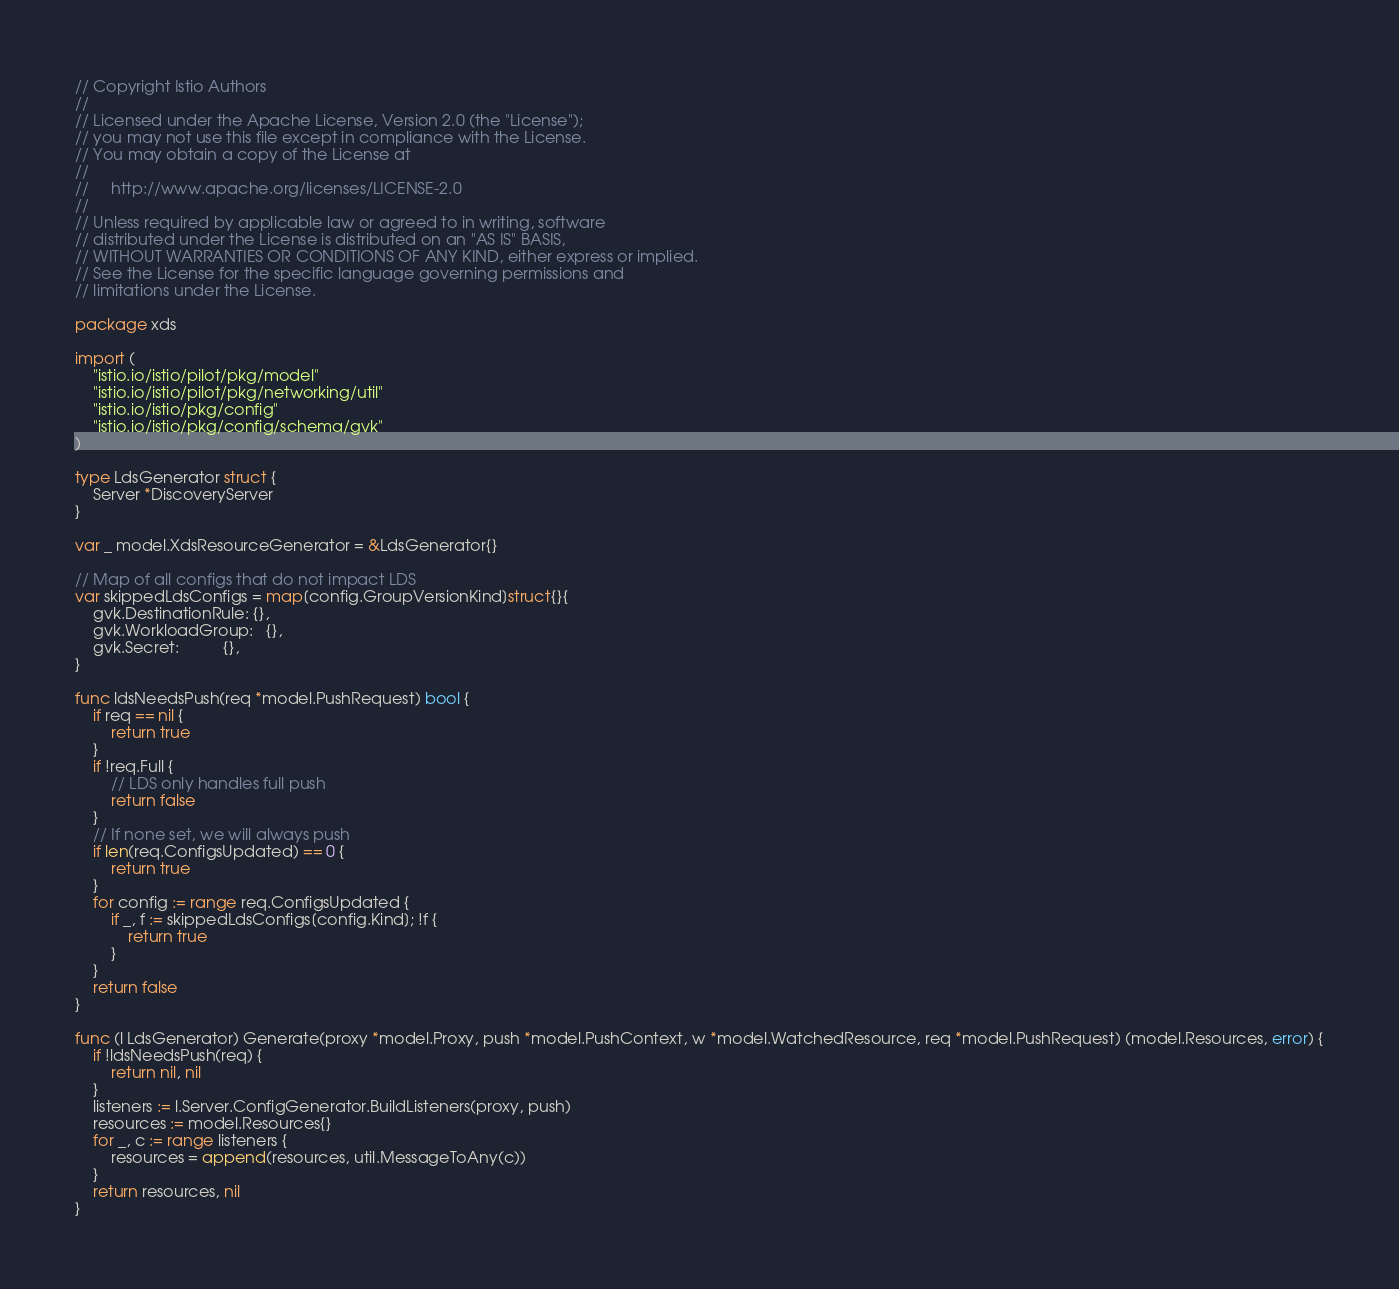Convert code to text. <code><loc_0><loc_0><loc_500><loc_500><_Go_>// Copyright Istio Authors
//
// Licensed under the Apache License, Version 2.0 (the "License");
// you may not use this file except in compliance with the License.
// You may obtain a copy of the License at
//
//     http://www.apache.org/licenses/LICENSE-2.0
//
// Unless required by applicable law or agreed to in writing, software
// distributed under the License is distributed on an "AS IS" BASIS,
// WITHOUT WARRANTIES OR CONDITIONS OF ANY KIND, either express or implied.
// See the License for the specific language governing permissions and
// limitations under the License.

package xds

import (
	"istio.io/istio/pilot/pkg/model"
	"istio.io/istio/pilot/pkg/networking/util"
	"istio.io/istio/pkg/config"
	"istio.io/istio/pkg/config/schema/gvk"
)

type LdsGenerator struct {
	Server *DiscoveryServer
}

var _ model.XdsResourceGenerator = &LdsGenerator{}

// Map of all configs that do not impact LDS
var skippedLdsConfigs = map[config.GroupVersionKind]struct{}{
	gvk.DestinationRule: {},
	gvk.WorkloadGroup:   {},
	gvk.Secret:          {},
}

func ldsNeedsPush(req *model.PushRequest) bool {
	if req == nil {
		return true
	}
	if !req.Full {
		// LDS only handles full push
		return false
	}
	// If none set, we will always push
	if len(req.ConfigsUpdated) == 0 {
		return true
	}
	for config := range req.ConfigsUpdated {
		if _, f := skippedLdsConfigs[config.Kind]; !f {
			return true
		}
	}
	return false
}

func (l LdsGenerator) Generate(proxy *model.Proxy, push *model.PushContext, w *model.WatchedResource, req *model.PushRequest) (model.Resources, error) {
	if !ldsNeedsPush(req) {
		return nil, nil
	}
	listeners := l.Server.ConfigGenerator.BuildListeners(proxy, push)
	resources := model.Resources{}
	for _, c := range listeners {
		resources = append(resources, util.MessageToAny(c))
	}
	return resources, nil
}
</code> 